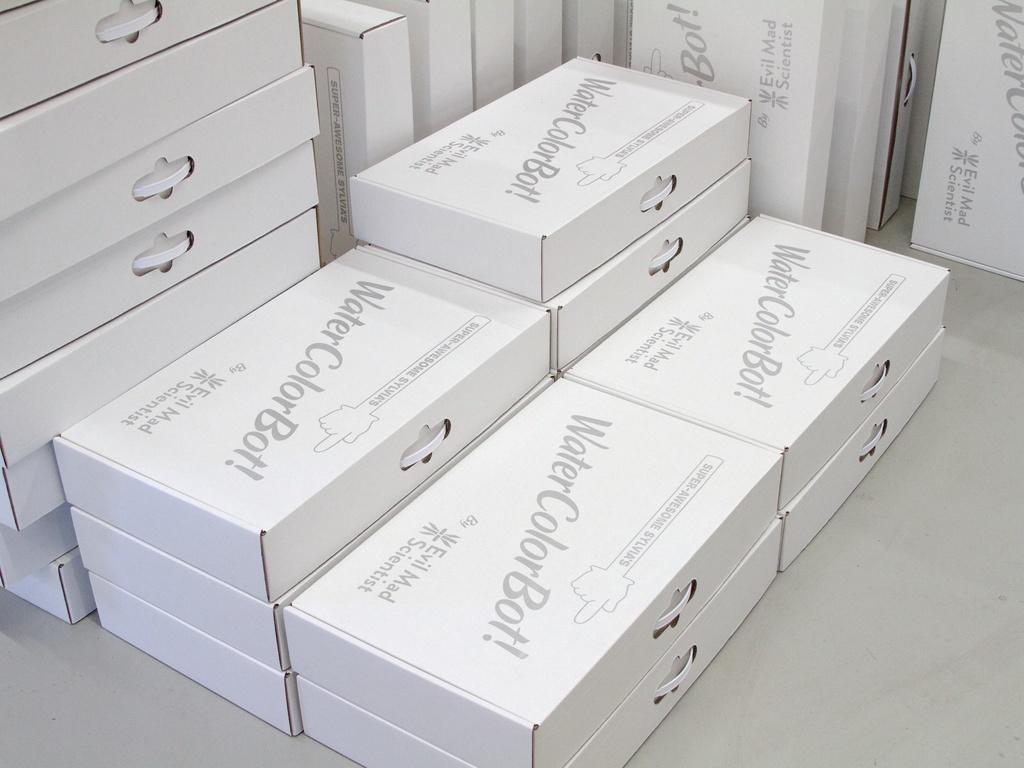What objects are present in the image? There are multiple boxes in the image. How are the boxes arranged in the image? The boxes are stacked on top of each other. Where are the boxes located in the image? The boxes are on the floor. What type of company is depicted on the boxes in the image? There is no company name or logo visible on the boxes in the image. How many flies can be seen on the boxes in the image? There are no flies present in the image. 